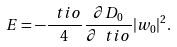Convert formula to latex. <formula><loc_0><loc_0><loc_500><loc_500>E = - \frac { \ t i o } { 4 } \frac { \partial D _ { 0 } } { \partial \ t i o } | w _ { 0 } | ^ { 2 } .</formula> 